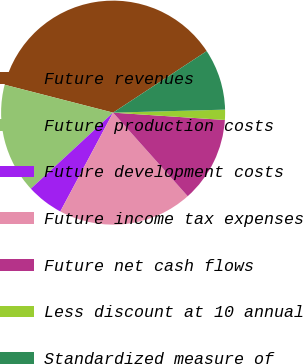Convert chart to OTSL. <chart><loc_0><loc_0><loc_500><loc_500><pie_chart><fcel>Future revenues<fcel>Future production costs<fcel>Future development costs<fcel>Future income tax expenses<fcel>Future net cash flows<fcel>Less discount at 10 annual<fcel>Standardized measure of<nl><fcel>36.74%<fcel>15.89%<fcel>5.31%<fcel>19.41%<fcel>12.36%<fcel>1.47%<fcel>8.83%<nl></chart> 